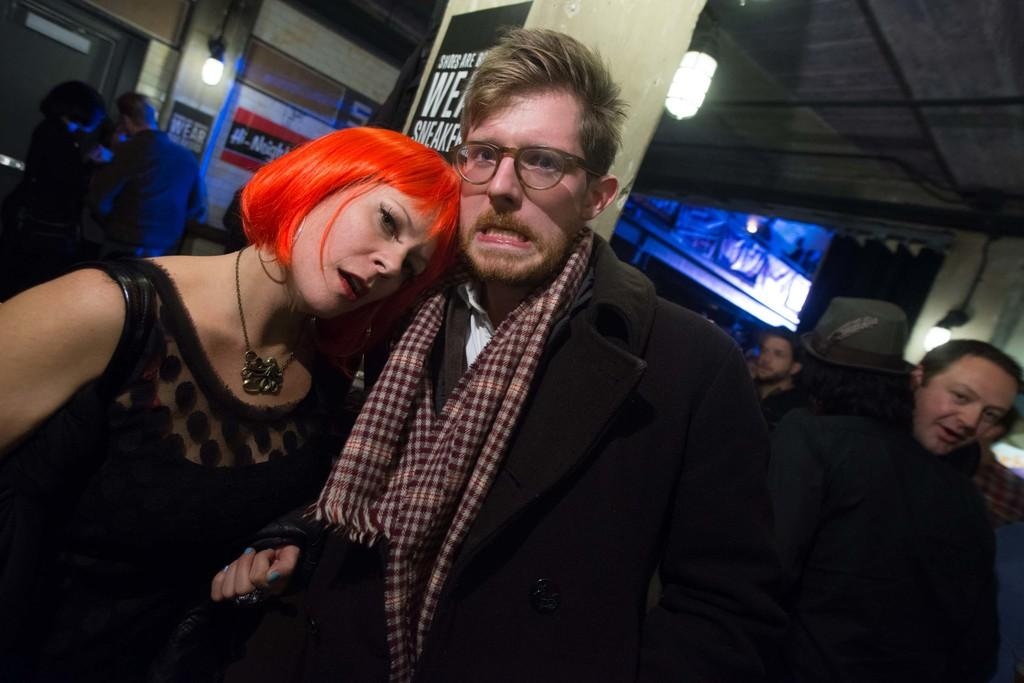How many people are in the group that is visible in the image? There is a group of people in the image. Can you describe any specific features of the people in the group? One man in the group is wearing spectacles, and one person is wearing a cap. What can be seen in the background of the image? There are lights, posters, and other objects visible in the background of the image. What type of underwear is the man wearing in the image? There is no information about the man's underwear in the image, as it is not visible or mentioned in the provided facts. How many ants can be seen crawling on the cap of the person in the image? There are no ants visible in the image, and therefore no such activity can be observed. 